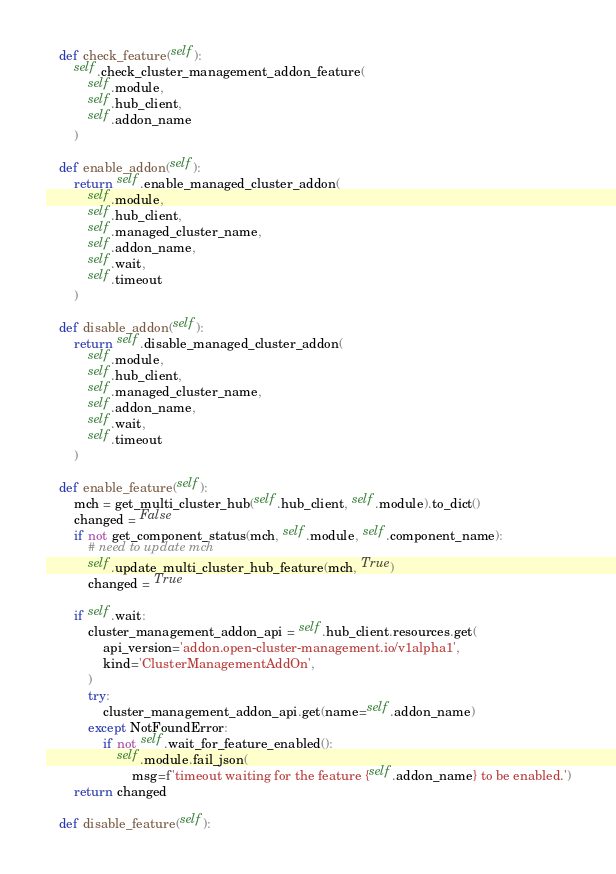Convert code to text. <code><loc_0><loc_0><loc_500><loc_500><_Python_>    def check_feature(self):
        self.check_cluster_management_addon_feature(
            self.module,
            self.hub_client,
            self.addon_name
        )

    def enable_addon(self):
        return self.enable_managed_cluster_addon(
            self.module,
            self.hub_client,
            self.managed_cluster_name,
            self.addon_name,
            self.wait,
            self.timeout
        )

    def disable_addon(self):
        return self.disable_managed_cluster_addon(
            self.module,
            self.hub_client,
            self.managed_cluster_name,
            self.addon_name,
            self.wait,
            self.timeout
        )

    def enable_feature(self):
        mch = get_multi_cluster_hub(self.hub_client, self.module).to_dict()
        changed = False
        if not get_component_status(mch, self.module, self.component_name):
            # need to update mch
            self.update_multi_cluster_hub_feature(mch, True)
            changed = True

        if self.wait:
            cluster_management_addon_api = self.hub_client.resources.get(
                api_version='addon.open-cluster-management.io/v1alpha1',
                kind='ClusterManagementAddOn',
            )
            try:
                cluster_management_addon_api.get(name=self.addon_name)
            except NotFoundError:
                if not self.wait_for_feature_enabled():
                    self.module.fail_json(
                        msg=f'timeout waiting for the feature {self.addon_name} to be enabled.')
        return changed

    def disable_feature(self):</code> 